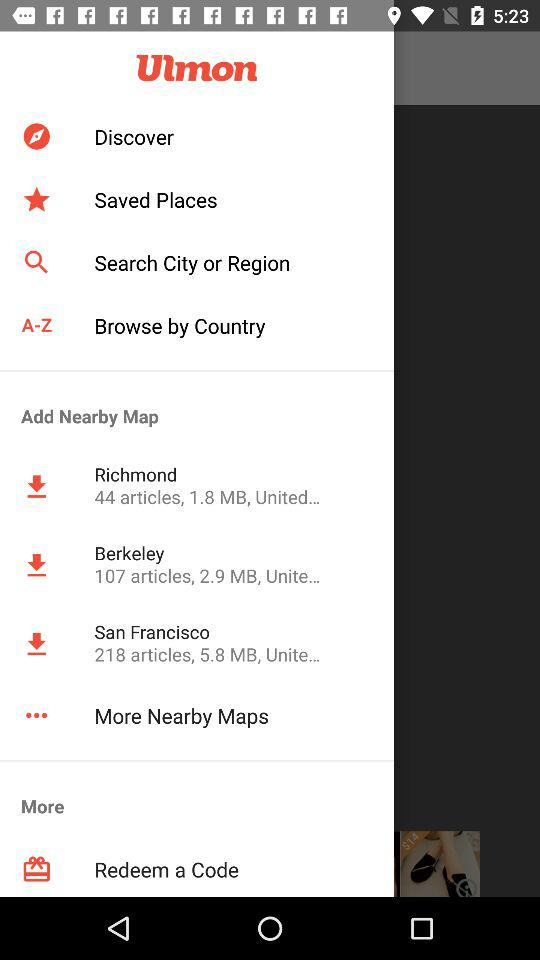218 articles are present on which map? The map on which 218 articles are present is San Francisco. 